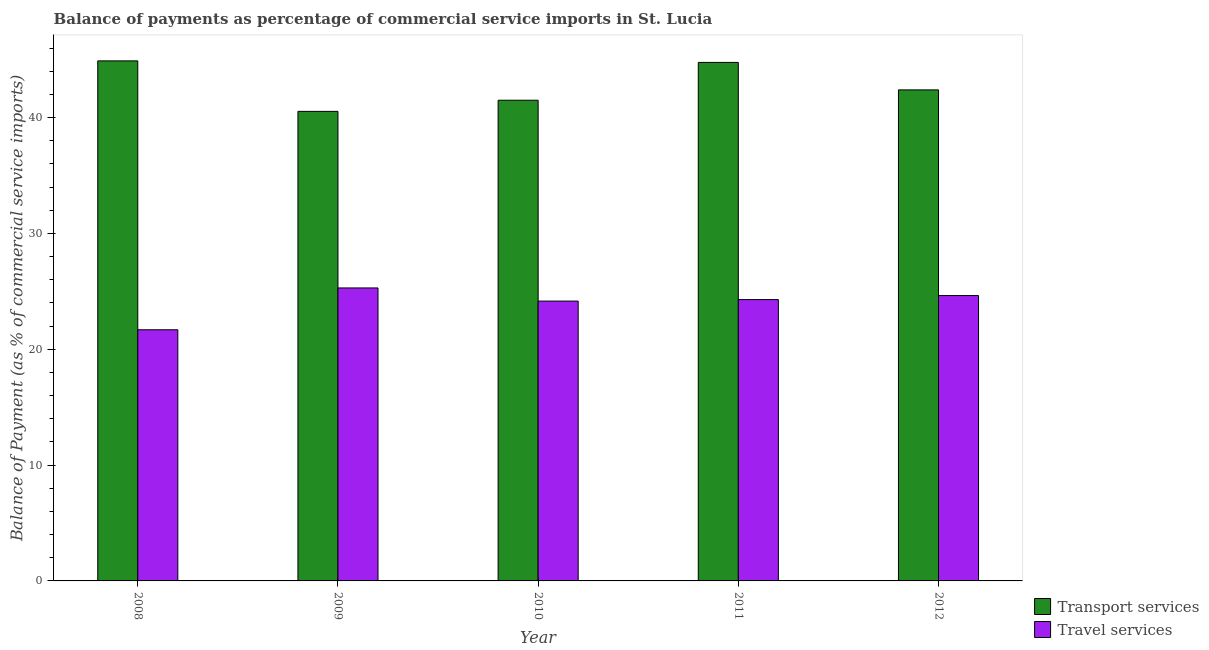How many different coloured bars are there?
Keep it short and to the point. 2. How many groups of bars are there?
Your response must be concise. 5. Are the number of bars on each tick of the X-axis equal?
Offer a very short reply. Yes. How many bars are there on the 1st tick from the left?
Give a very brief answer. 2. How many bars are there on the 4th tick from the right?
Offer a terse response. 2. What is the balance of payments of transport services in 2011?
Provide a short and direct response. 44.77. Across all years, what is the maximum balance of payments of transport services?
Keep it short and to the point. 44.9. Across all years, what is the minimum balance of payments of transport services?
Keep it short and to the point. 40.54. In which year was the balance of payments of transport services maximum?
Give a very brief answer. 2008. In which year was the balance of payments of transport services minimum?
Your response must be concise. 2009. What is the total balance of payments of transport services in the graph?
Ensure brevity in your answer.  214.09. What is the difference between the balance of payments of travel services in 2008 and that in 2012?
Keep it short and to the point. -2.95. What is the difference between the balance of payments of transport services in 2012 and the balance of payments of travel services in 2010?
Ensure brevity in your answer.  0.89. What is the average balance of payments of travel services per year?
Your response must be concise. 24.01. In the year 2008, what is the difference between the balance of payments of travel services and balance of payments of transport services?
Your answer should be very brief. 0. In how many years, is the balance of payments of transport services greater than 14 %?
Keep it short and to the point. 5. What is the ratio of the balance of payments of transport services in 2008 to that in 2009?
Provide a succinct answer. 1.11. What is the difference between the highest and the second highest balance of payments of travel services?
Provide a short and direct response. 0.66. What is the difference between the highest and the lowest balance of payments of travel services?
Ensure brevity in your answer.  3.61. What does the 1st bar from the left in 2011 represents?
Provide a short and direct response. Transport services. What does the 2nd bar from the right in 2008 represents?
Your answer should be very brief. Transport services. Are all the bars in the graph horizontal?
Provide a succinct answer. No. Does the graph contain grids?
Your answer should be compact. No. How many legend labels are there?
Make the answer very short. 2. How are the legend labels stacked?
Provide a succinct answer. Vertical. What is the title of the graph?
Offer a very short reply. Balance of payments as percentage of commercial service imports in St. Lucia. Does "Central government" appear as one of the legend labels in the graph?
Offer a terse response. No. What is the label or title of the Y-axis?
Make the answer very short. Balance of Payment (as % of commercial service imports). What is the Balance of Payment (as % of commercial service imports) in Transport services in 2008?
Your answer should be compact. 44.9. What is the Balance of Payment (as % of commercial service imports) in Travel services in 2008?
Give a very brief answer. 21.68. What is the Balance of Payment (as % of commercial service imports) in Transport services in 2009?
Offer a very short reply. 40.54. What is the Balance of Payment (as % of commercial service imports) in Travel services in 2009?
Your answer should be compact. 25.29. What is the Balance of Payment (as % of commercial service imports) of Transport services in 2010?
Make the answer very short. 41.5. What is the Balance of Payment (as % of commercial service imports) of Travel services in 2010?
Offer a very short reply. 24.16. What is the Balance of Payment (as % of commercial service imports) in Transport services in 2011?
Give a very brief answer. 44.77. What is the Balance of Payment (as % of commercial service imports) of Travel services in 2011?
Make the answer very short. 24.29. What is the Balance of Payment (as % of commercial service imports) of Transport services in 2012?
Offer a terse response. 42.39. What is the Balance of Payment (as % of commercial service imports) in Travel services in 2012?
Give a very brief answer. 24.64. Across all years, what is the maximum Balance of Payment (as % of commercial service imports) in Transport services?
Give a very brief answer. 44.9. Across all years, what is the maximum Balance of Payment (as % of commercial service imports) of Travel services?
Your answer should be very brief. 25.29. Across all years, what is the minimum Balance of Payment (as % of commercial service imports) of Transport services?
Offer a very short reply. 40.54. Across all years, what is the minimum Balance of Payment (as % of commercial service imports) of Travel services?
Provide a short and direct response. 21.68. What is the total Balance of Payment (as % of commercial service imports) of Transport services in the graph?
Provide a short and direct response. 214.09. What is the total Balance of Payment (as % of commercial service imports) of Travel services in the graph?
Offer a very short reply. 120.06. What is the difference between the Balance of Payment (as % of commercial service imports) of Transport services in 2008 and that in 2009?
Give a very brief answer. 4.36. What is the difference between the Balance of Payment (as % of commercial service imports) in Travel services in 2008 and that in 2009?
Your answer should be very brief. -3.61. What is the difference between the Balance of Payment (as % of commercial service imports) of Transport services in 2008 and that in 2010?
Offer a very short reply. 3.4. What is the difference between the Balance of Payment (as % of commercial service imports) in Travel services in 2008 and that in 2010?
Your answer should be compact. -2.48. What is the difference between the Balance of Payment (as % of commercial service imports) of Transport services in 2008 and that in 2011?
Keep it short and to the point. 0.13. What is the difference between the Balance of Payment (as % of commercial service imports) of Travel services in 2008 and that in 2011?
Your answer should be compact. -2.6. What is the difference between the Balance of Payment (as % of commercial service imports) in Transport services in 2008 and that in 2012?
Ensure brevity in your answer.  2.5. What is the difference between the Balance of Payment (as % of commercial service imports) in Travel services in 2008 and that in 2012?
Your answer should be compact. -2.95. What is the difference between the Balance of Payment (as % of commercial service imports) of Transport services in 2009 and that in 2010?
Provide a succinct answer. -0.96. What is the difference between the Balance of Payment (as % of commercial service imports) in Travel services in 2009 and that in 2010?
Provide a succinct answer. 1.14. What is the difference between the Balance of Payment (as % of commercial service imports) in Transport services in 2009 and that in 2011?
Your answer should be very brief. -4.23. What is the difference between the Balance of Payment (as % of commercial service imports) of Travel services in 2009 and that in 2011?
Provide a succinct answer. 1.01. What is the difference between the Balance of Payment (as % of commercial service imports) of Transport services in 2009 and that in 2012?
Offer a very short reply. -1.86. What is the difference between the Balance of Payment (as % of commercial service imports) of Travel services in 2009 and that in 2012?
Your response must be concise. 0.66. What is the difference between the Balance of Payment (as % of commercial service imports) in Transport services in 2010 and that in 2011?
Your answer should be very brief. -3.27. What is the difference between the Balance of Payment (as % of commercial service imports) of Travel services in 2010 and that in 2011?
Your answer should be very brief. -0.13. What is the difference between the Balance of Payment (as % of commercial service imports) of Transport services in 2010 and that in 2012?
Offer a very short reply. -0.89. What is the difference between the Balance of Payment (as % of commercial service imports) in Travel services in 2010 and that in 2012?
Offer a terse response. -0.48. What is the difference between the Balance of Payment (as % of commercial service imports) in Transport services in 2011 and that in 2012?
Keep it short and to the point. 2.37. What is the difference between the Balance of Payment (as % of commercial service imports) of Travel services in 2011 and that in 2012?
Provide a short and direct response. -0.35. What is the difference between the Balance of Payment (as % of commercial service imports) in Transport services in 2008 and the Balance of Payment (as % of commercial service imports) in Travel services in 2009?
Your answer should be compact. 19.6. What is the difference between the Balance of Payment (as % of commercial service imports) in Transport services in 2008 and the Balance of Payment (as % of commercial service imports) in Travel services in 2010?
Keep it short and to the point. 20.74. What is the difference between the Balance of Payment (as % of commercial service imports) in Transport services in 2008 and the Balance of Payment (as % of commercial service imports) in Travel services in 2011?
Give a very brief answer. 20.61. What is the difference between the Balance of Payment (as % of commercial service imports) of Transport services in 2008 and the Balance of Payment (as % of commercial service imports) of Travel services in 2012?
Your answer should be compact. 20.26. What is the difference between the Balance of Payment (as % of commercial service imports) in Transport services in 2009 and the Balance of Payment (as % of commercial service imports) in Travel services in 2010?
Offer a terse response. 16.38. What is the difference between the Balance of Payment (as % of commercial service imports) of Transport services in 2009 and the Balance of Payment (as % of commercial service imports) of Travel services in 2011?
Offer a very short reply. 16.25. What is the difference between the Balance of Payment (as % of commercial service imports) in Transport services in 2009 and the Balance of Payment (as % of commercial service imports) in Travel services in 2012?
Ensure brevity in your answer.  15.9. What is the difference between the Balance of Payment (as % of commercial service imports) of Transport services in 2010 and the Balance of Payment (as % of commercial service imports) of Travel services in 2011?
Provide a short and direct response. 17.21. What is the difference between the Balance of Payment (as % of commercial service imports) in Transport services in 2010 and the Balance of Payment (as % of commercial service imports) in Travel services in 2012?
Your response must be concise. 16.86. What is the difference between the Balance of Payment (as % of commercial service imports) of Transport services in 2011 and the Balance of Payment (as % of commercial service imports) of Travel services in 2012?
Offer a terse response. 20.13. What is the average Balance of Payment (as % of commercial service imports) in Transport services per year?
Your answer should be very brief. 42.82. What is the average Balance of Payment (as % of commercial service imports) in Travel services per year?
Provide a short and direct response. 24.01. In the year 2008, what is the difference between the Balance of Payment (as % of commercial service imports) of Transport services and Balance of Payment (as % of commercial service imports) of Travel services?
Your answer should be very brief. 23.21. In the year 2009, what is the difference between the Balance of Payment (as % of commercial service imports) of Transport services and Balance of Payment (as % of commercial service imports) of Travel services?
Provide a succinct answer. 15.24. In the year 2010, what is the difference between the Balance of Payment (as % of commercial service imports) of Transport services and Balance of Payment (as % of commercial service imports) of Travel services?
Give a very brief answer. 17.34. In the year 2011, what is the difference between the Balance of Payment (as % of commercial service imports) of Transport services and Balance of Payment (as % of commercial service imports) of Travel services?
Your response must be concise. 20.48. In the year 2012, what is the difference between the Balance of Payment (as % of commercial service imports) of Transport services and Balance of Payment (as % of commercial service imports) of Travel services?
Keep it short and to the point. 17.76. What is the ratio of the Balance of Payment (as % of commercial service imports) of Transport services in 2008 to that in 2009?
Give a very brief answer. 1.11. What is the ratio of the Balance of Payment (as % of commercial service imports) of Travel services in 2008 to that in 2009?
Give a very brief answer. 0.86. What is the ratio of the Balance of Payment (as % of commercial service imports) in Transport services in 2008 to that in 2010?
Give a very brief answer. 1.08. What is the ratio of the Balance of Payment (as % of commercial service imports) in Travel services in 2008 to that in 2010?
Offer a very short reply. 0.9. What is the ratio of the Balance of Payment (as % of commercial service imports) in Travel services in 2008 to that in 2011?
Offer a terse response. 0.89. What is the ratio of the Balance of Payment (as % of commercial service imports) of Transport services in 2008 to that in 2012?
Offer a terse response. 1.06. What is the ratio of the Balance of Payment (as % of commercial service imports) in Travel services in 2008 to that in 2012?
Offer a very short reply. 0.88. What is the ratio of the Balance of Payment (as % of commercial service imports) in Transport services in 2009 to that in 2010?
Provide a short and direct response. 0.98. What is the ratio of the Balance of Payment (as % of commercial service imports) in Travel services in 2009 to that in 2010?
Offer a terse response. 1.05. What is the ratio of the Balance of Payment (as % of commercial service imports) in Transport services in 2009 to that in 2011?
Offer a terse response. 0.91. What is the ratio of the Balance of Payment (as % of commercial service imports) of Travel services in 2009 to that in 2011?
Give a very brief answer. 1.04. What is the ratio of the Balance of Payment (as % of commercial service imports) of Transport services in 2009 to that in 2012?
Make the answer very short. 0.96. What is the ratio of the Balance of Payment (as % of commercial service imports) in Travel services in 2009 to that in 2012?
Provide a succinct answer. 1.03. What is the ratio of the Balance of Payment (as % of commercial service imports) in Transport services in 2010 to that in 2011?
Give a very brief answer. 0.93. What is the ratio of the Balance of Payment (as % of commercial service imports) in Travel services in 2010 to that in 2011?
Your answer should be very brief. 0.99. What is the ratio of the Balance of Payment (as % of commercial service imports) in Transport services in 2010 to that in 2012?
Your response must be concise. 0.98. What is the ratio of the Balance of Payment (as % of commercial service imports) of Travel services in 2010 to that in 2012?
Offer a very short reply. 0.98. What is the ratio of the Balance of Payment (as % of commercial service imports) in Transport services in 2011 to that in 2012?
Offer a very short reply. 1.06. What is the ratio of the Balance of Payment (as % of commercial service imports) of Travel services in 2011 to that in 2012?
Offer a terse response. 0.99. What is the difference between the highest and the second highest Balance of Payment (as % of commercial service imports) of Transport services?
Offer a terse response. 0.13. What is the difference between the highest and the second highest Balance of Payment (as % of commercial service imports) of Travel services?
Provide a succinct answer. 0.66. What is the difference between the highest and the lowest Balance of Payment (as % of commercial service imports) of Transport services?
Make the answer very short. 4.36. What is the difference between the highest and the lowest Balance of Payment (as % of commercial service imports) of Travel services?
Offer a very short reply. 3.61. 